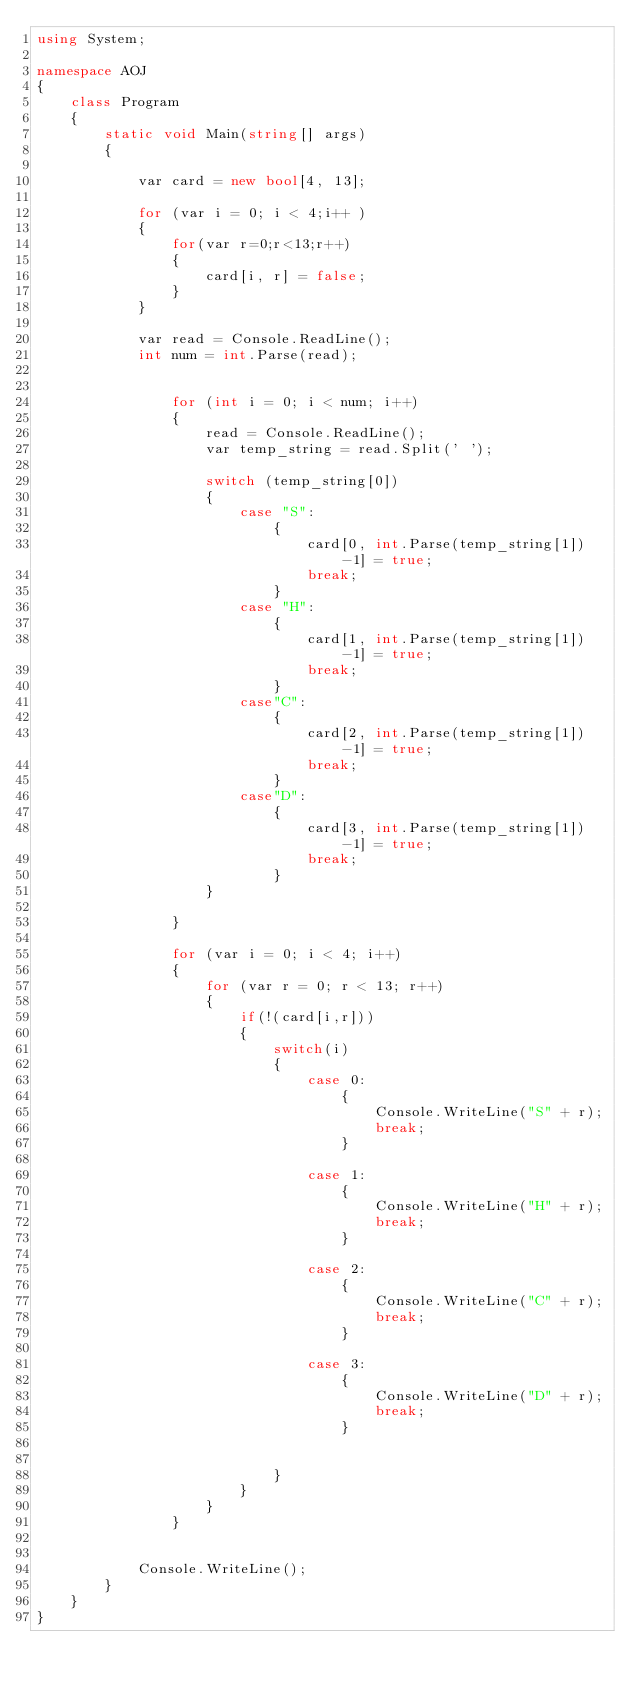Convert code to text. <code><loc_0><loc_0><loc_500><loc_500><_C#_>using System;

namespace AOJ
{
    class Program
    {
        static void Main(string[] args)
        {

            var card = new bool[4, 13];

            for (var i = 0; i < 4;i++ )
            {
                for(var r=0;r<13;r++)
                {
                    card[i, r] = false;
                }
            }

            var read = Console.ReadLine();
            int num = int.Parse(read);


                for (int i = 0; i < num; i++)
                {
                    read = Console.ReadLine();
                    var temp_string = read.Split(' ');

                    switch (temp_string[0])
                    {
                        case "S":
                            {
                                card[0, int.Parse(temp_string[1])-1] = true;
                                break;
                            }
                        case "H":
                            {
                                card[1, int.Parse(temp_string[1])-1] = true;
                                break;
                            }
                        case"C":
                            {
                                card[2, int.Parse(temp_string[1])-1] = true;
                                break;
                            }
                        case"D":
                            {
                                card[3, int.Parse(temp_string[1])-1] = true;
                                break;
                            }
                    }

                }

                for (var i = 0; i < 4; i++)
                {
                    for (var r = 0; r < 13; r++)
                    {
                        if(!(card[i,r]))
                        {
                            switch(i)
                            {
                                case 0:
                                    {
                                        Console.WriteLine("S" + r);
                                        break;
                                    }

                                case 1:
                                    {
                                        Console.WriteLine("H" + r);
                                        break;
                                    }

                                case 2:
                                    {
                                        Console.WriteLine("C" + r);
                                        break;
                                    }

                                case 3:
                                    {
                                        Console.WriteLine("D" + r);
                                        break;
                                    }


                            }
                        }
                    }
                }
            

            Console.WriteLine();
        }
    }
}</code> 